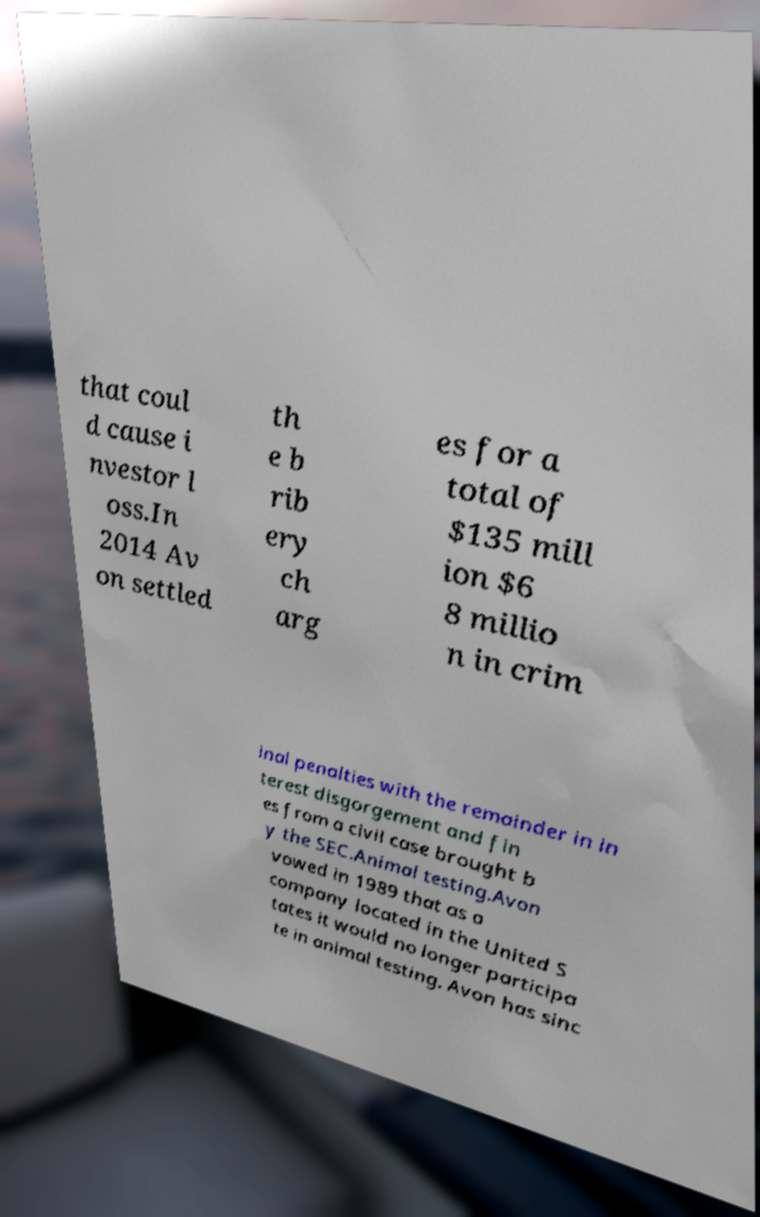Can you accurately transcribe the text from the provided image for me? that coul d cause i nvestor l oss.In 2014 Av on settled th e b rib ery ch arg es for a total of $135 mill ion $6 8 millio n in crim inal penalties with the remainder in in terest disgorgement and fin es from a civil case brought b y the SEC.Animal testing.Avon vowed in 1989 that as a company located in the United S tates it would no longer participa te in animal testing. Avon has sinc 